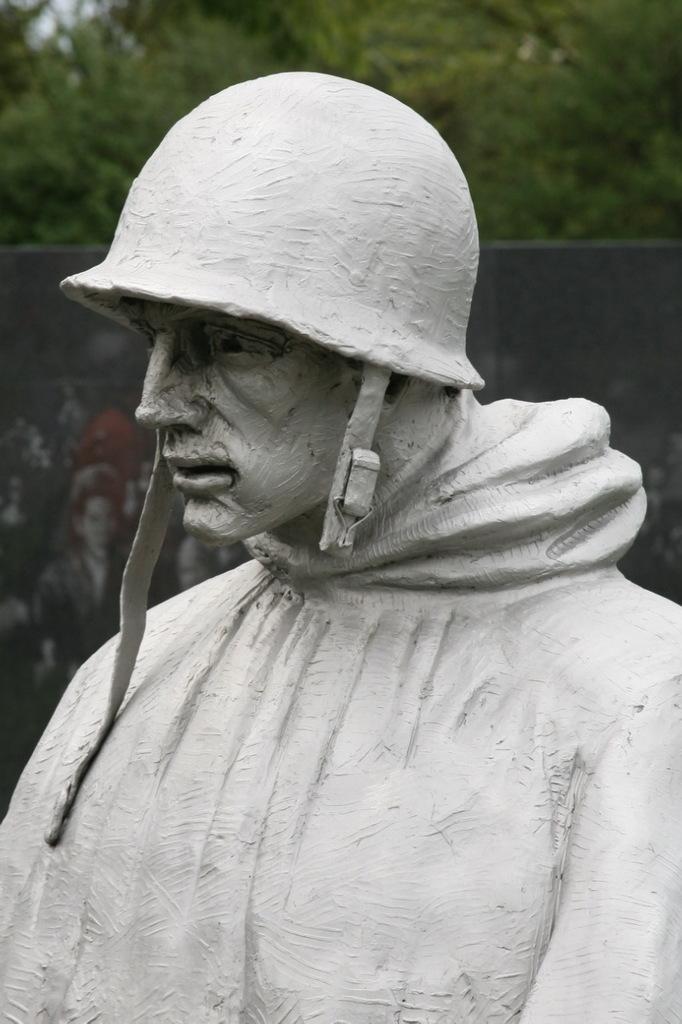Please provide a concise description of this image. This picture is clicked outside. In the foreground we can see the sculpture of a person wearing a helmet. In the background we can see the trees and the depictions of people on an object which seems to be the board. 